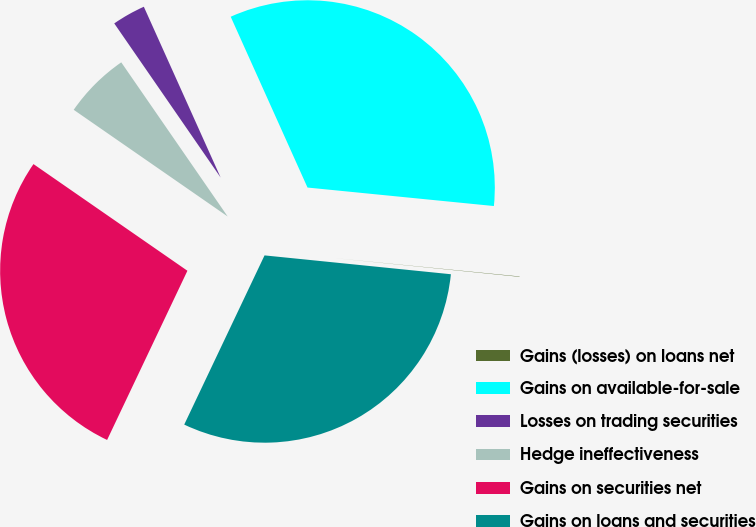Convert chart to OTSL. <chart><loc_0><loc_0><loc_500><loc_500><pie_chart><fcel>Gains (losses) on loans net<fcel>Gains on available-for-sale<fcel>Losses on trading securities<fcel>Hedge ineffectiveness<fcel>Gains on securities net<fcel>Gains on loans and securities<nl><fcel>0.03%<fcel>33.3%<fcel>2.89%<fcel>5.74%<fcel>27.59%<fcel>30.45%<nl></chart> 